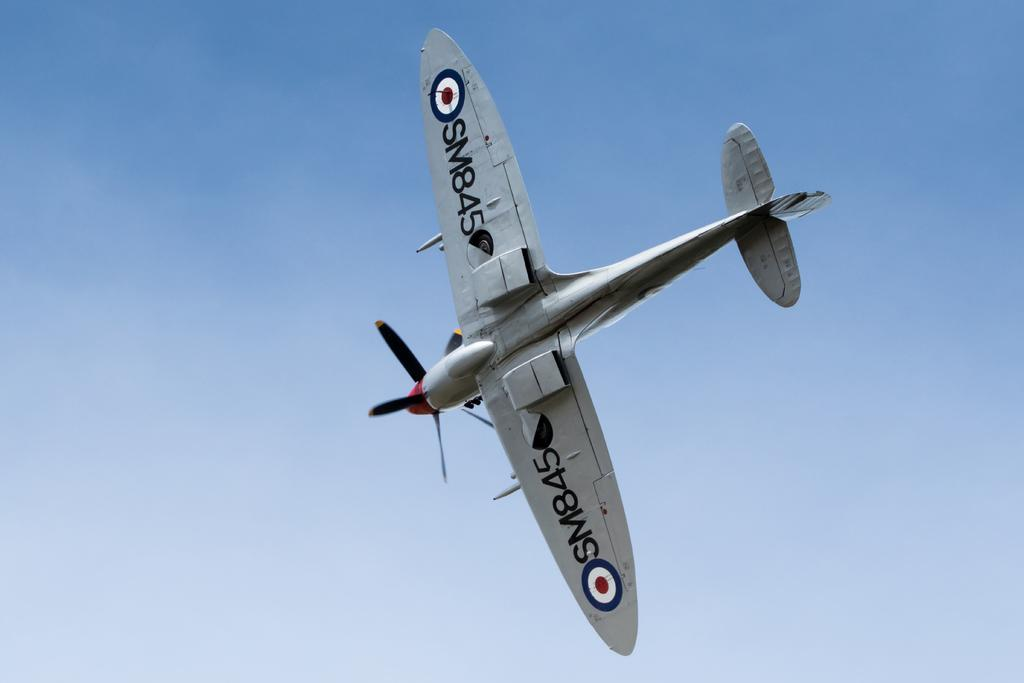<image>
Relay a brief, clear account of the picture shown. A propeller plane is labeled with the identification tag SM845 on the underside of its wings. 